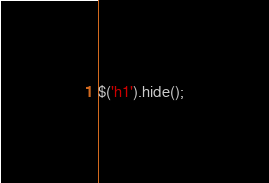<code> <loc_0><loc_0><loc_500><loc_500><_JavaScript_>$('h1').hide();</code> 